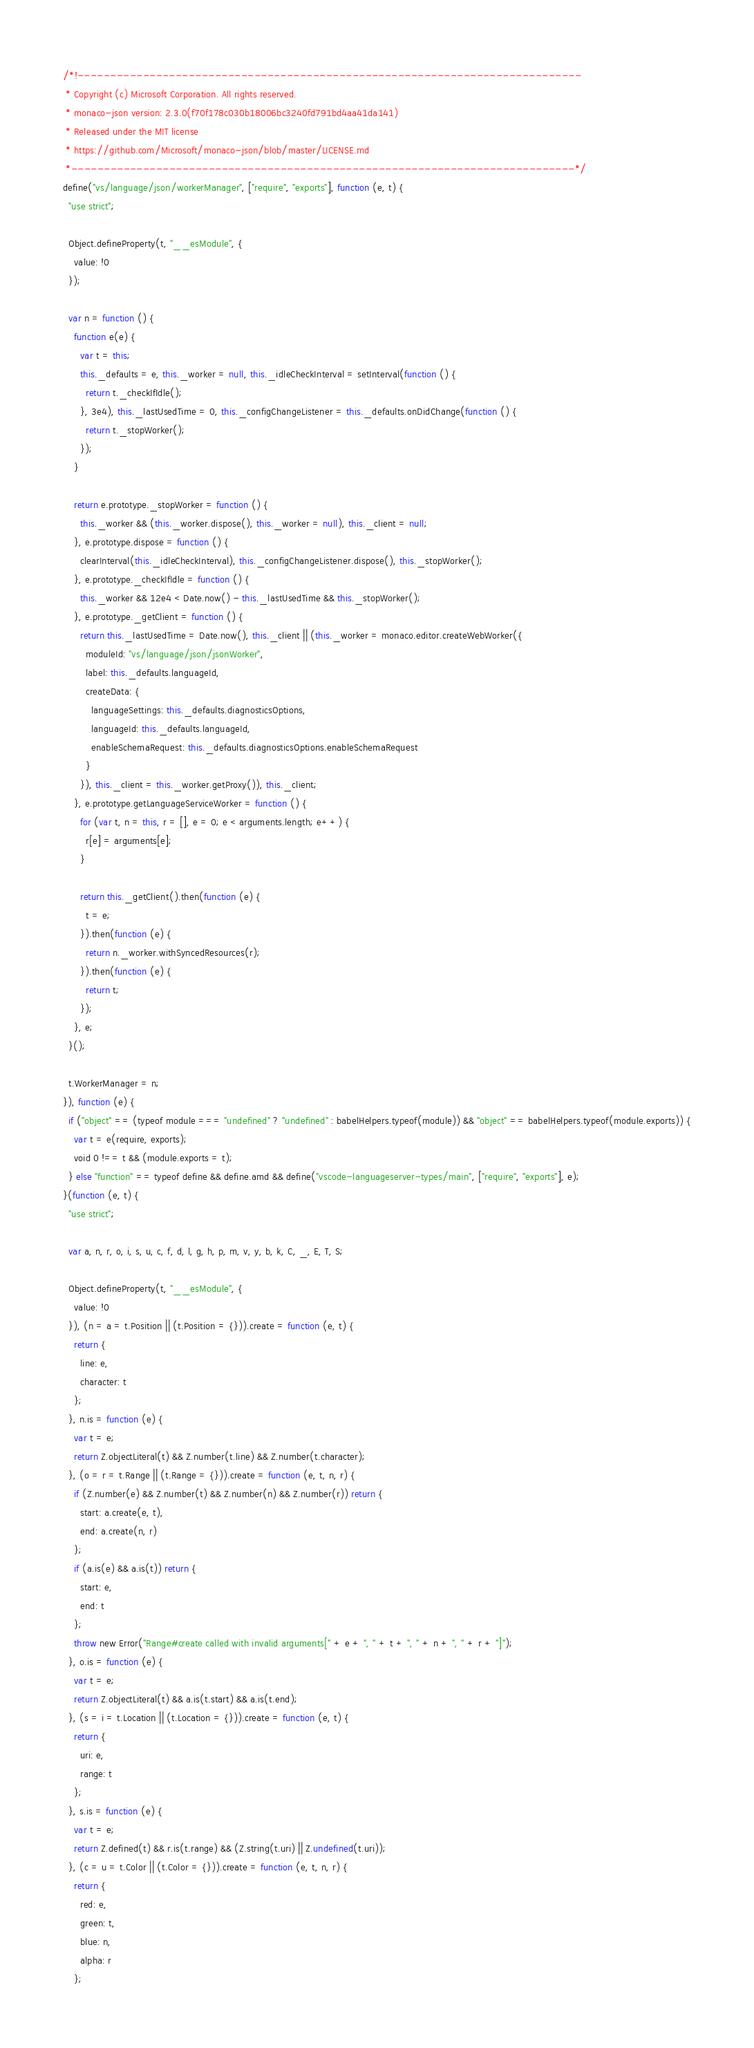<code> <loc_0><loc_0><loc_500><loc_500><_JavaScript_>/*!-----------------------------------------------------------------------------
 * Copyright (c) Microsoft Corporation. All rights reserved.
 * monaco-json version: 2.3.0(f70f178c030b18006bc3240fd791bd4aa41da141)
 * Released under the MIT license
 * https://github.com/Microsoft/monaco-json/blob/master/LICENSE.md
 *-----------------------------------------------------------------------------*/
define("vs/language/json/workerManager", ["require", "exports"], function (e, t) {
  "use strict";

  Object.defineProperty(t, "__esModule", {
    value: !0
  });

  var n = function () {
    function e(e) {
      var t = this;
      this._defaults = e, this._worker = null, this._idleCheckInterval = setInterval(function () {
        return t._checkIfIdle();
      }, 3e4), this._lastUsedTime = 0, this._configChangeListener = this._defaults.onDidChange(function () {
        return t._stopWorker();
      });
    }

    return e.prototype._stopWorker = function () {
      this._worker && (this._worker.dispose(), this._worker = null), this._client = null;
    }, e.prototype.dispose = function () {
      clearInterval(this._idleCheckInterval), this._configChangeListener.dispose(), this._stopWorker();
    }, e.prototype._checkIfIdle = function () {
      this._worker && 12e4 < Date.now() - this._lastUsedTime && this._stopWorker();
    }, e.prototype._getClient = function () {
      return this._lastUsedTime = Date.now(), this._client || (this._worker = monaco.editor.createWebWorker({
        moduleId: "vs/language/json/jsonWorker",
        label: this._defaults.languageId,
        createData: {
          languageSettings: this._defaults.diagnosticsOptions,
          languageId: this._defaults.languageId,
          enableSchemaRequest: this._defaults.diagnosticsOptions.enableSchemaRequest
        }
      }), this._client = this._worker.getProxy()), this._client;
    }, e.prototype.getLanguageServiceWorker = function () {
      for (var t, n = this, r = [], e = 0; e < arguments.length; e++) {
        r[e] = arguments[e];
      }

      return this._getClient().then(function (e) {
        t = e;
      }).then(function (e) {
        return n._worker.withSyncedResources(r);
      }).then(function (e) {
        return t;
      });
    }, e;
  }();

  t.WorkerManager = n;
}), function (e) {
  if ("object" == (typeof module === "undefined" ? "undefined" : babelHelpers.typeof(module)) && "object" == babelHelpers.typeof(module.exports)) {
    var t = e(require, exports);
    void 0 !== t && (module.exports = t);
  } else "function" == typeof define && define.amd && define("vscode-languageserver-types/main", ["require", "exports"], e);
}(function (e, t) {
  "use strict";

  var a, n, r, o, i, s, u, c, f, d, l, g, h, p, m, v, y, b, k, C, _, E, T, S;

  Object.defineProperty(t, "__esModule", {
    value: !0
  }), (n = a = t.Position || (t.Position = {})).create = function (e, t) {
    return {
      line: e,
      character: t
    };
  }, n.is = function (e) {
    var t = e;
    return Z.objectLiteral(t) && Z.number(t.line) && Z.number(t.character);
  }, (o = r = t.Range || (t.Range = {})).create = function (e, t, n, r) {
    if (Z.number(e) && Z.number(t) && Z.number(n) && Z.number(r)) return {
      start: a.create(e, t),
      end: a.create(n, r)
    };
    if (a.is(e) && a.is(t)) return {
      start: e,
      end: t
    };
    throw new Error("Range#create called with invalid arguments[" + e + ", " + t + ", " + n + ", " + r + "]");
  }, o.is = function (e) {
    var t = e;
    return Z.objectLiteral(t) && a.is(t.start) && a.is(t.end);
  }, (s = i = t.Location || (t.Location = {})).create = function (e, t) {
    return {
      uri: e,
      range: t
    };
  }, s.is = function (e) {
    var t = e;
    return Z.defined(t) && r.is(t.range) && (Z.string(t.uri) || Z.undefined(t.uri));
  }, (c = u = t.Color || (t.Color = {})).create = function (e, t, n, r) {
    return {
      red: e,
      green: t,
      blue: n,
      alpha: r
    };</code> 